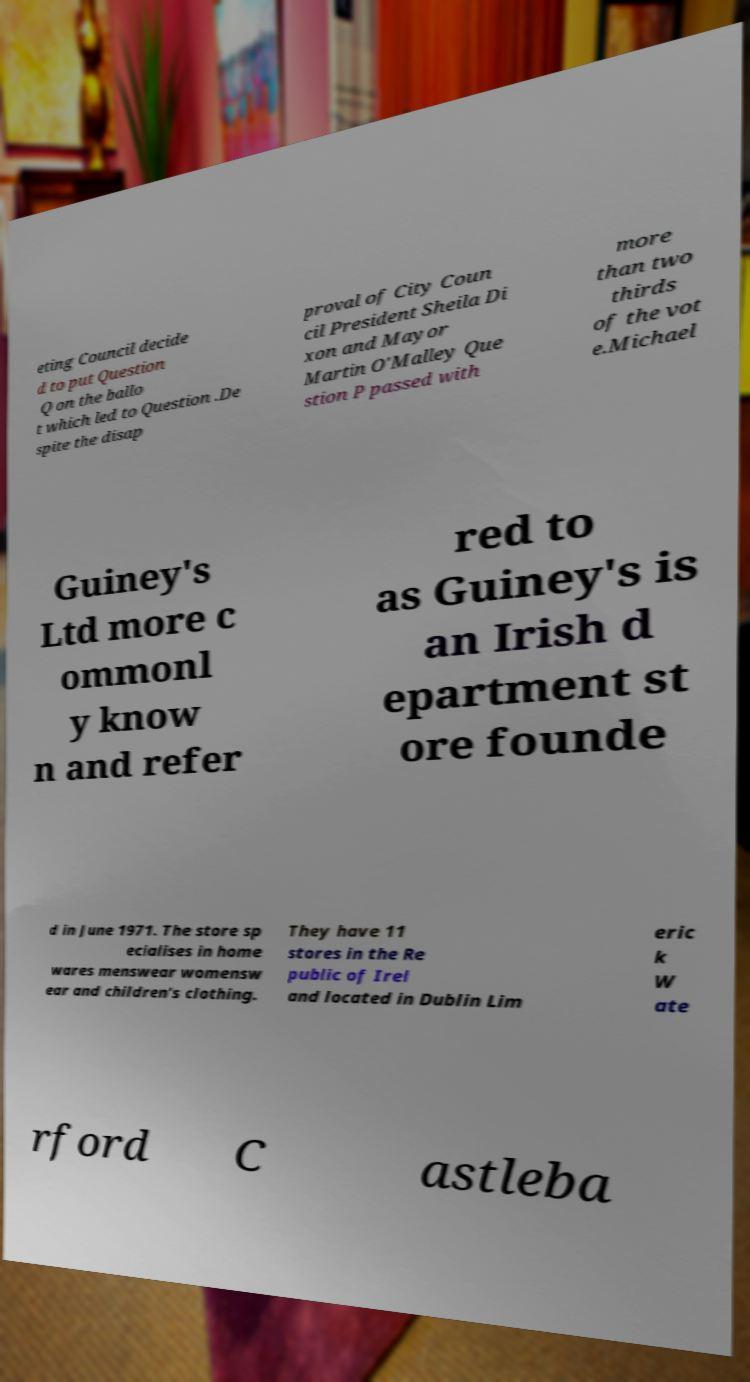Could you extract and type out the text from this image? eting Council decide d to put Question Q on the ballo t which led to Question .De spite the disap proval of City Coun cil President Sheila Di xon and Mayor Martin O'Malley Que stion P passed with more than two thirds of the vot e.Michael Guiney's Ltd more c ommonl y know n and refer red to as Guiney's is an Irish d epartment st ore founde d in June 1971. The store sp ecialises in home wares menswear womensw ear and children's clothing. They have 11 stores in the Re public of Irel and located in Dublin Lim eric k W ate rford C astleba 